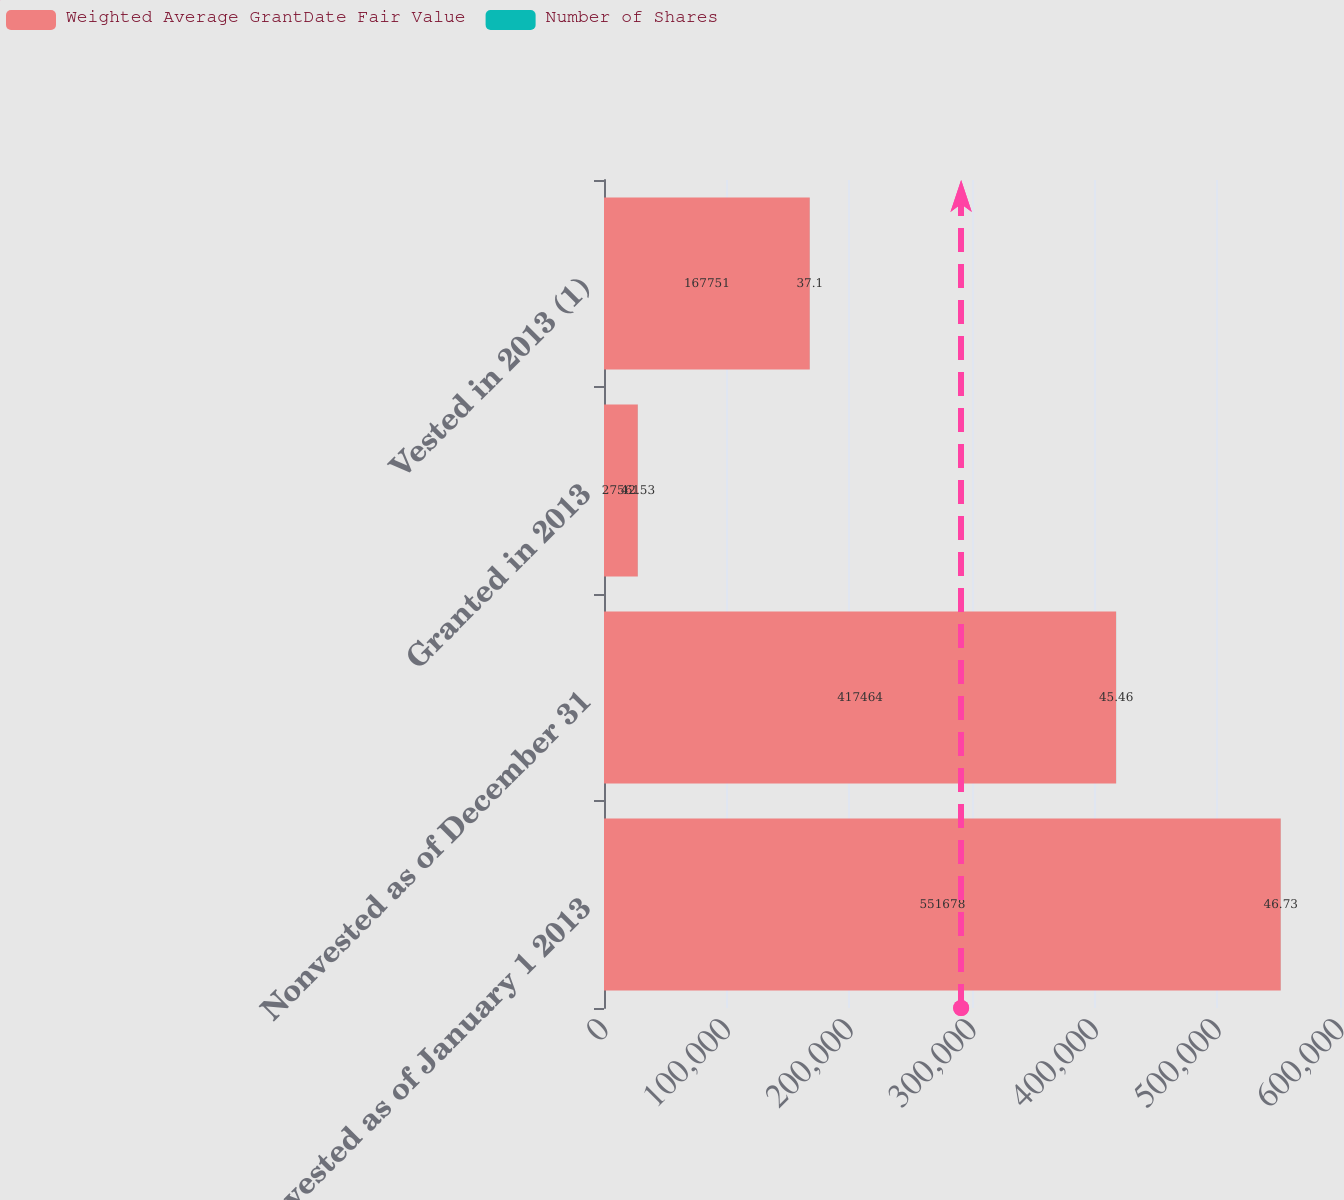<chart> <loc_0><loc_0><loc_500><loc_500><stacked_bar_chart><ecel><fcel>Nonvested as of January 1 2013<fcel>Nonvested as of December 31<fcel>Granted in 2013<fcel>Vested in 2013 (1)<nl><fcel>Weighted Average GrantDate Fair Value<fcel>551678<fcel>417464<fcel>27561<fcel>167751<nl><fcel>Number of Shares<fcel>46.73<fcel>45.46<fcel>42.53<fcel>37.1<nl></chart> 